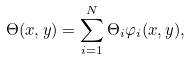<formula> <loc_0><loc_0><loc_500><loc_500>\Theta ( x , y ) = \sum _ { i = 1 } ^ { N } \Theta _ { i } \varphi _ { i } ( x , y ) ,</formula> 